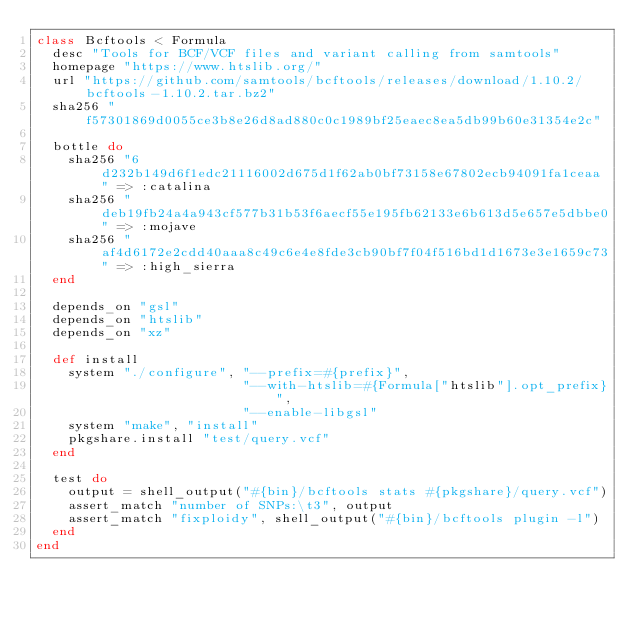<code> <loc_0><loc_0><loc_500><loc_500><_Ruby_>class Bcftools < Formula
  desc "Tools for BCF/VCF files and variant calling from samtools"
  homepage "https://www.htslib.org/"
  url "https://github.com/samtools/bcftools/releases/download/1.10.2/bcftools-1.10.2.tar.bz2"
  sha256 "f57301869d0055ce3b8e26d8ad880c0c1989bf25eaec8ea5db99b60e31354e2c"

  bottle do
    sha256 "6d232b149d6f1edc21116002d675d1f62ab0bf73158e67802ecb94091fa1ceaa" => :catalina
    sha256 "deb19fb24a4a943cf577b31b53f6aecf55e195fb62133e6b613d5e657e5dbbe0" => :mojave
    sha256 "af4d6172e2cdd40aaa8c49c6e4e8fde3cb90bf7f04f516bd1d1673e3e1659c73" => :high_sierra
  end

  depends_on "gsl"
  depends_on "htslib"
  depends_on "xz"

  def install
    system "./configure", "--prefix=#{prefix}",
                          "--with-htslib=#{Formula["htslib"].opt_prefix}",
                          "--enable-libgsl"
    system "make", "install"
    pkgshare.install "test/query.vcf"
  end

  test do
    output = shell_output("#{bin}/bcftools stats #{pkgshare}/query.vcf")
    assert_match "number of SNPs:\t3", output
    assert_match "fixploidy", shell_output("#{bin}/bcftools plugin -l")
  end
end
</code> 